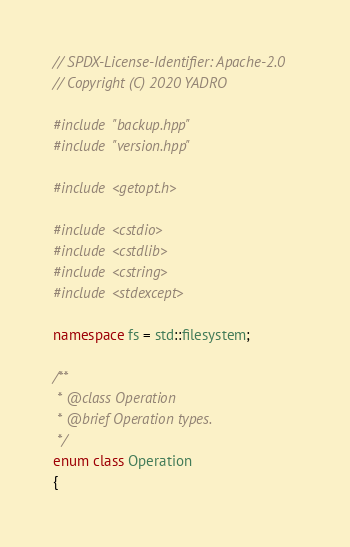Convert code to text. <code><loc_0><loc_0><loc_500><loc_500><_C++_>// SPDX-License-Identifier: Apache-2.0
// Copyright (C) 2020 YADRO

#include "backup.hpp"
#include "version.hpp"

#include <getopt.h>

#include <cstdio>
#include <cstdlib>
#include <cstring>
#include <stdexcept>

namespace fs = std::filesystem;

/**
 * @class Operation
 * @brief Operation types.
 */
enum class Operation
{</code> 